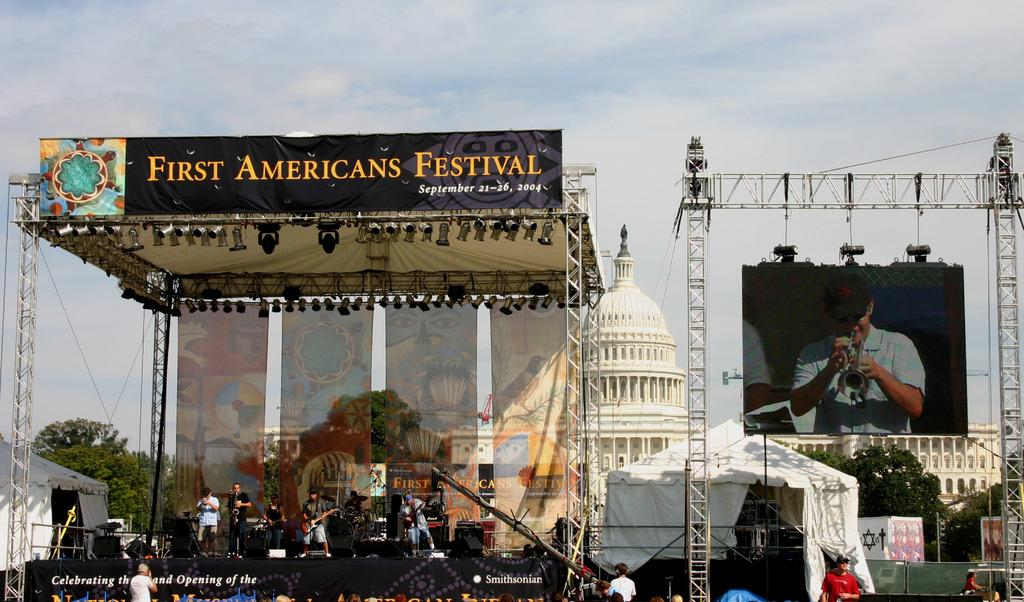<image>
Offer a succinct explanation of the picture presented. A First Americans Festival sign hangs above a stage. 